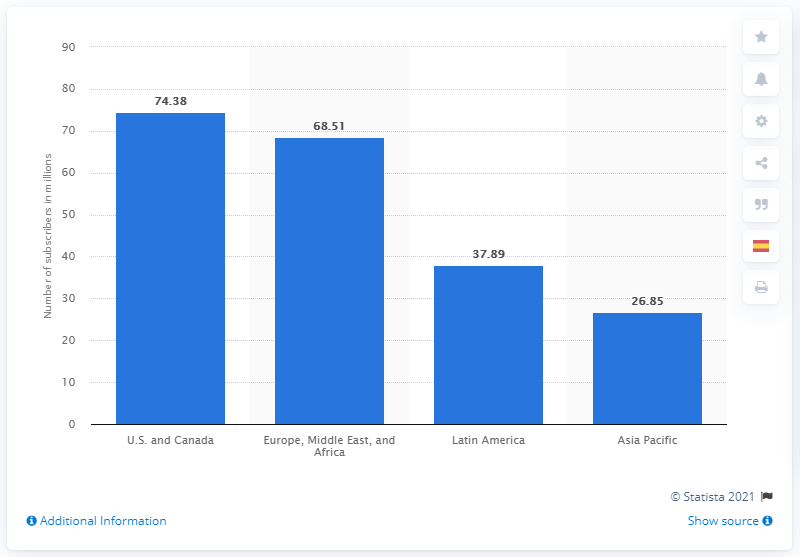Specify some key components in this picture. Netflix had approximately 74,380 paying subscribers in the first quarter of 2021. Netflix has identified the smallest market in which it operates as the Asia Pacific region. 